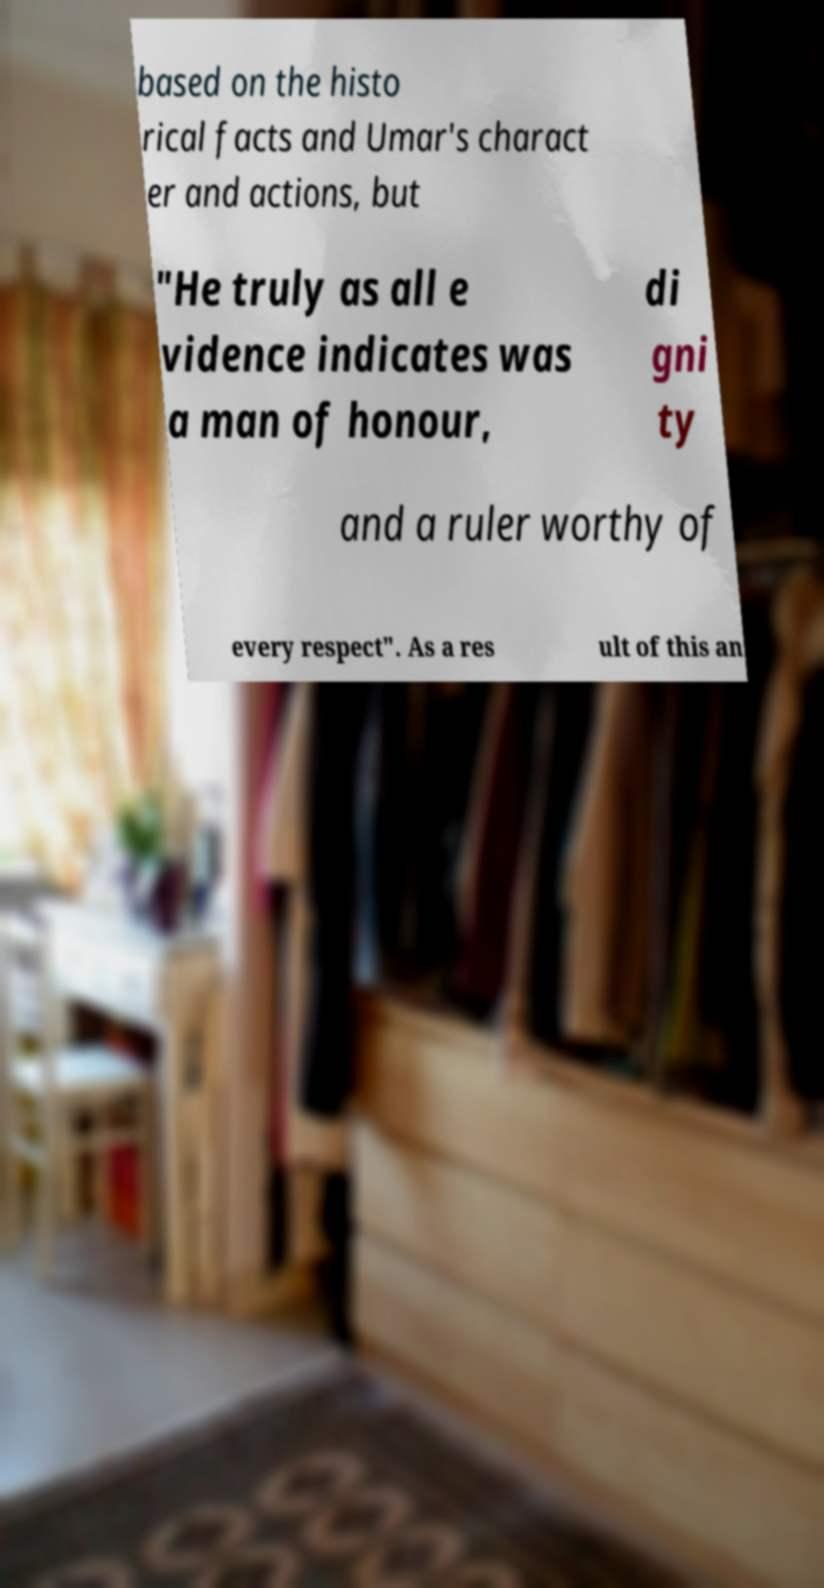Please identify and transcribe the text found in this image. based on the histo rical facts and Umar's charact er and actions, but "He truly as all e vidence indicates was a man of honour, di gni ty and a ruler worthy of every respect". As a res ult of this an 